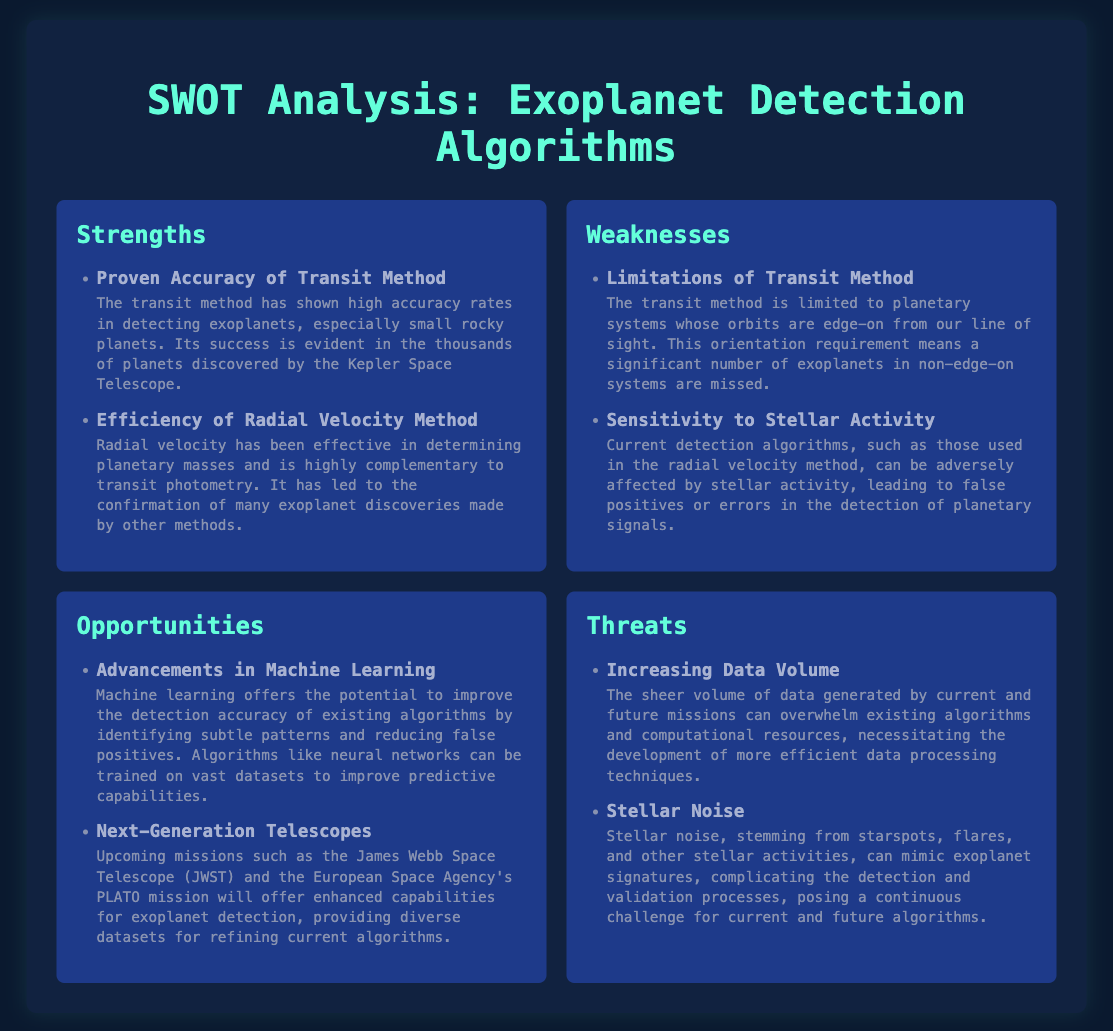what is one strength of the transit method? The document mentions the proven accuracy of the transit method as a strength, highlighting its success in detecting small rocky planets.
Answer: Proven Accuracy of Transit Method what are the two methods mentioned for exoplanet detection? The document specifically identifies the transit method and the radial velocity method as the two detection methods.
Answer: Transit Method and Radial Velocity Method what is a weakness associated with the transit method? The document lists limitations of the transit method, specifically its reliance on edge-on orientations of planetary systems.
Answer: Limitations of Transit Method what potential advancement can improve detection accuracy? The document mentions that advancements in machine learning can enhance detection algorithms by minimizing false positives.
Answer: Advancements in Machine Learning name a future mission that will help with exoplanet detection. The document highlights the James Webb Space Telescope (JWST) as a significant upcoming mission for detecting exoplanets.
Answer: James Webb Space Telescope what is a threat posed by increasing data volume? The document states that the growing amount of data may overwhelm existing algorithms and computational resources.
Answer: Overwhelming existing algorithms what does stellar noise complicate in the detection process? According to the document, stellar noise mimics exoplanet signatures, complicating detection and validation.
Answer: Detection and validation processes which method is efficient in determining planetary masses? The document asserts that the radial velocity method is efficient for determining the masses of exoplanets.
Answer: Radial Velocity Method 